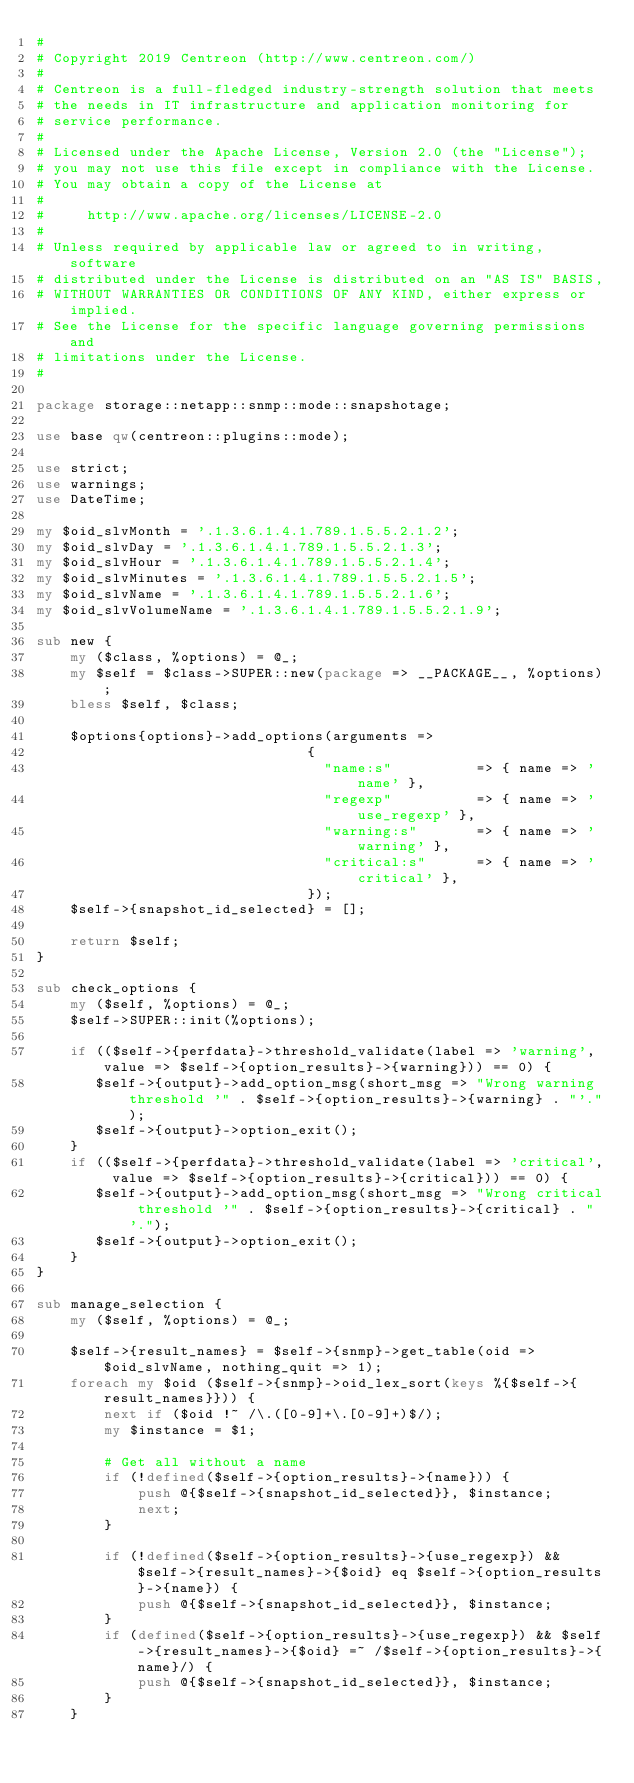<code> <loc_0><loc_0><loc_500><loc_500><_Perl_>#
# Copyright 2019 Centreon (http://www.centreon.com/)
#
# Centreon is a full-fledged industry-strength solution that meets
# the needs in IT infrastructure and application monitoring for
# service performance.
#
# Licensed under the Apache License, Version 2.0 (the "License");
# you may not use this file except in compliance with the License.
# You may obtain a copy of the License at
#
#     http://www.apache.org/licenses/LICENSE-2.0
#
# Unless required by applicable law or agreed to in writing, software
# distributed under the License is distributed on an "AS IS" BASIS,
# WITHOUT WARRANTIES OR CONDITIONS OF ANY KIND, either express or implied.
# See the License for the specific language governing permissions and
# limitations under the License.
#

package storage::netapp::snmp::mode::snapshotage;

use base qw(centreon::plugins::mode);

use strict;
use warnings;
use DateTime;

my $oid_slvMonth = '.1.3.6.1.4.1.789.1.5.5.2.1.2';
my $oid_slvDay = '.1.3.6.1.4.1.789.1.5.5.2.1.3';
my $oid_slvHour = '.1.3.6.1.4.1.789.1.5.5.2.1.4';
my $oid_slvMinutes = '.1.3.6.1.4.1.789.1.5.5.2.1.5';
my $oid_slvName = '.1.3.6.1.4.1.789.1.5.5.2.1.6';
my $oid_slvVolumeName = '.1.3.6.1.4.1.789.1.5.5.2.1.9';

sub new {
    my ($class, %options) = @_;
    my $self = $class->SUPER::new(package => __PACKAGE__, %options);
    bless $self, $class;
    
    $options{options}->add_options(arguments =>
                                {
                                  "name:s"          => { name => 'name' },
                                  "regexp"          => { name => 'use_regexp' },
                                  "warning:s"       => { name => 'warning' },
                                  "critical:s"      => { name => 'critical' },
                                });
    $self->{snapshot_id_selected} = [];
    
    return $self;
}

sub check_options {
    my ($self, %options) = @_;
    $self->SUPER::init(%options);

    if (($self->{perfdata}->threshold_validate(label => 'warning', value => $self->{option_results}->{warning})) == 0) {
       $self->{output}->add_option_msg(short_msg => "Wrong warning threshold '" . $self->{option_results}->{warning} . "'.");
       $self->{output}->option_exit();
    }
    if (($self->{perfdata}->threshold_validate(label => 'critical', value => $self->{option_results}->{critical})) == 0) {
       $self->{output}->add_option_msg(short_msg => "Wrong critical threshold '" . $self->{option_results}->{critical} . "'.");
       $self->{output}->option_exit();
    }    
}

sub manage_selection {
    my ($self, %options) = @_;

    $self->{result_names} = $self->{snmp}->get_table(oid => $oid_slvName, nothing_quit => 1);
    foreach my $oid ($self->{snmp}->oid_lex_sort(keys %{$self->{result_names}})) {
        next if ($oid !~ /\.([0-9]+\.[0-9]+)$/);
        my $instance = $1;

        # Get all without a name
        if (!defined($self->{option_results}->{name})) {
            push @{$self->{snapshot_id_selected}}, $instance; 
            next;
        }
        
        if (!defined($self->{option_results}->{use_regexp}) && $self->{result_names}->{$oid} eq $self->{option_results}->{name}) {
            push @{$self->{snapshot_id_selected}}, $instance; 
        }
        if (defined($self->{option_results}->{use_regexp}) && $self->{result_names}->{$oid} =~ /$self->{option_results}->{name}/) {
            push @{$self->{snapshot_id_selected}}, $instance;
        }
    }
</code> 